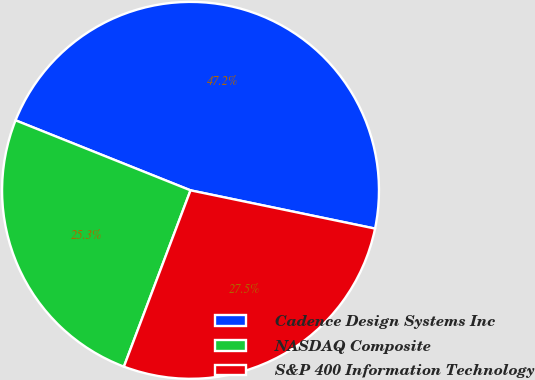Convert chart to OTSL. <chart><loc_0><loc_0><loc_500><loc_500><pie_chart><fcel>Cadence Design Systems Inc<fcel>NASDAQ Composite<fcel>S&P 400 Information Technology<nl><fcel>47.2%<fcel>25.31%<fcel>27.5%<nl></chart> 